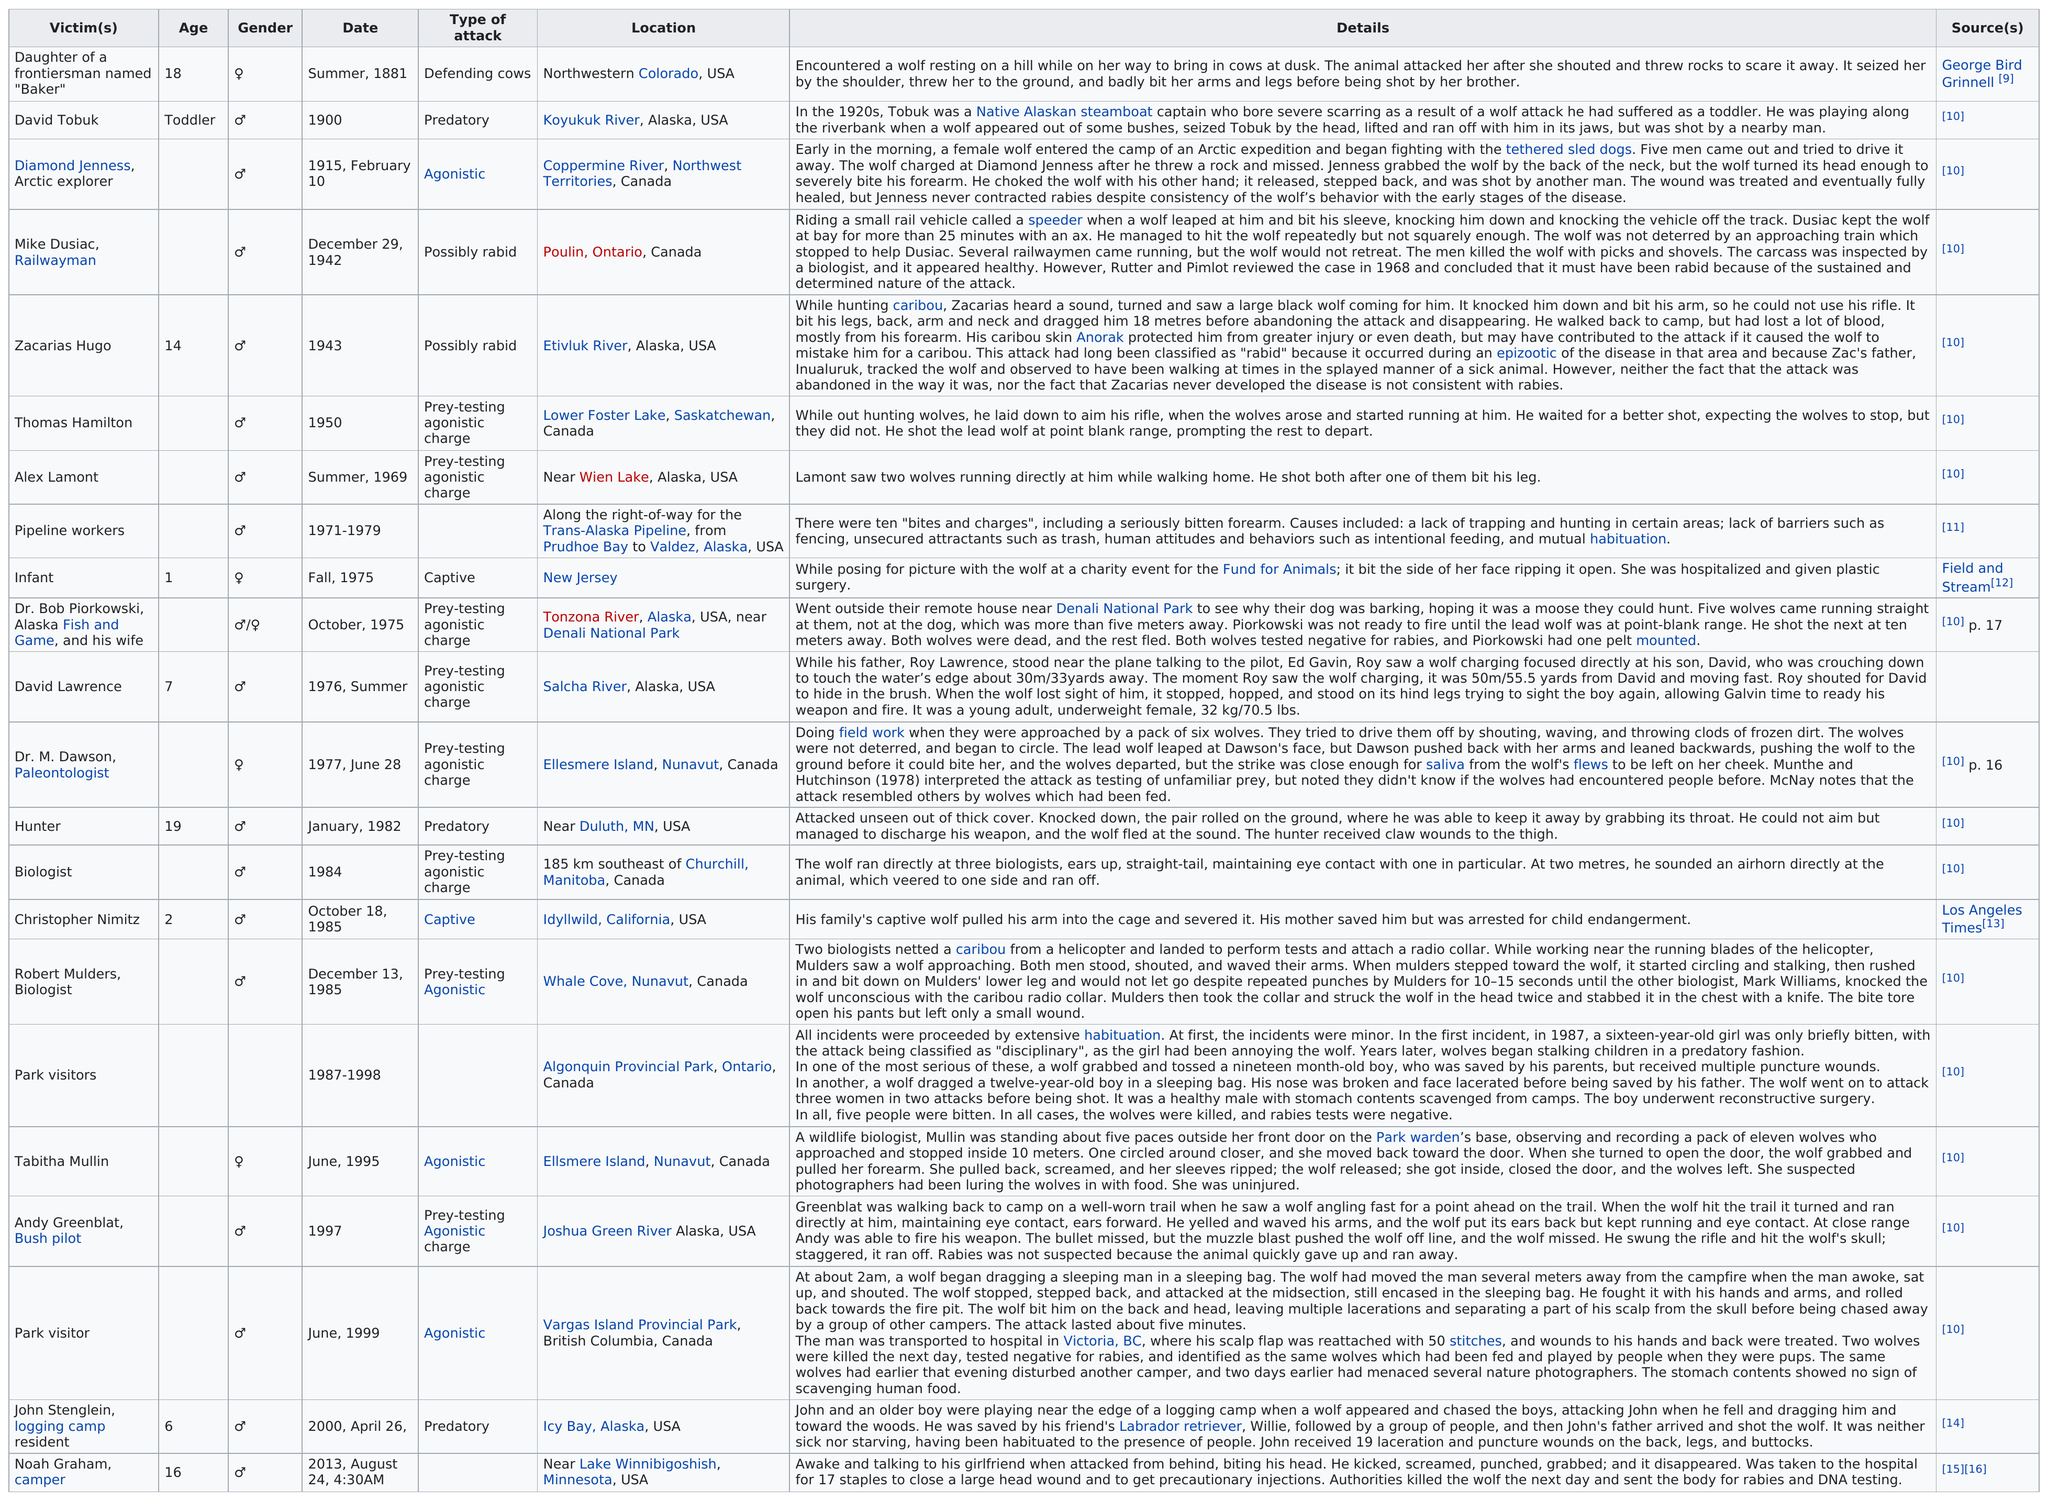Highlight a few significant elements in this photo. The wolf attack on David Tobuk was predatory in nature. There have been a total of 22 recorded non-fatal attacks by wolves. According to a park visitor who was attacked in June of 1999, approximately 50 stitches were required to treat their injuries. The average age of wolf attack victims is 10. Eight attacks have occurred in Alaska, USA. 